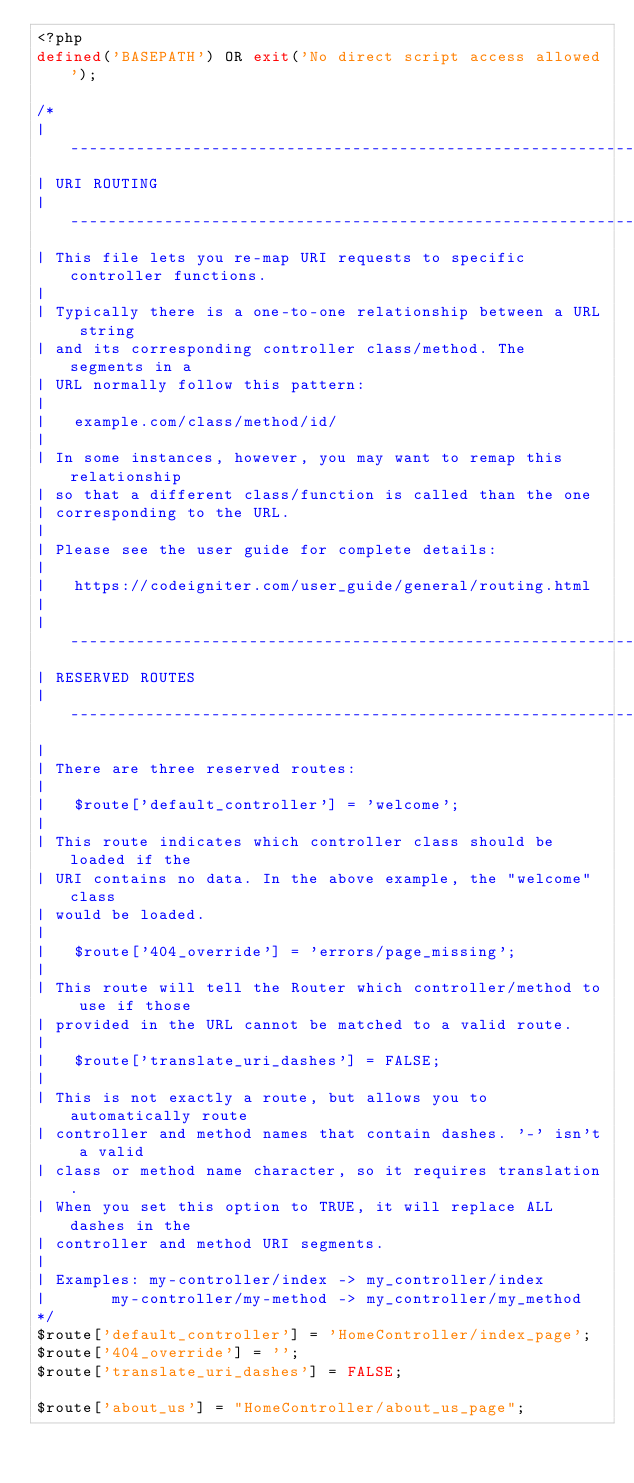Convert code to text. <code><loc_0><loc_0><loc_500><loc_500><_PHP_><?php
defined('BASEPATH') OR exit('No direct script access allowed');

/*
| -------------------------------------------------------------------------
| URI ROUTING
| -------------------------------------------------------------------------
| This file lets you re-map URI requests to specific controller functions.
|
| Typically there is a one-to-one relationship between a URL string
| and its corresponding controller class/method. The segments in a
| URL normally follow this pattern:
|
|	example.com/class/method/id/
|
| In some instances, however, you may want to remap this relationship
| so that a different class/function is called than the one
| corresponding to the URL.
|
| Please see the user guide for complete details:
|
|	https://codeigniter.com/user_guide/general/routing.html
|
| -------------------------------------------------------------------------
| RESERVED ROUTES
| -------------------------------------------------------------------------
|
| There are three reserved routes:
|
|	$route['default_controller'] = 'welcome';
|
| This route indicates which controller class should be loaded if the
| URI contains no data. In the above example, the "welcome" class
| would be loaded.
|
|	$route['404_override'] = 'errors/page_missing';
|
| This route will tell the Router which controller/method to use if those
| provided in the URL cannot be matched to a valid route.
|
|	$route['translate_uri_dashes'] = FALSE;
|
| This is not exactly a route, but allows you to automatically route
| controller and method names that contain dashes. '-' isn't a valid
| class or method name character, so it requires translation.
| When you set this option to TRUE, it will replace ALL dashes in the
| controller and method URI segments.
|
| Examples:	my-controller/index	-> my_controller/index
|		my-controller/my-method	-> my_controller/my_method
*/
$route['default_controller'] = 'HomeController/index_page';
$route['404_override'] = '';
$route['translate_uri_dashes'] = FALSE;

$route['about_us'] = "HomeController/about_us_page";


</code> 